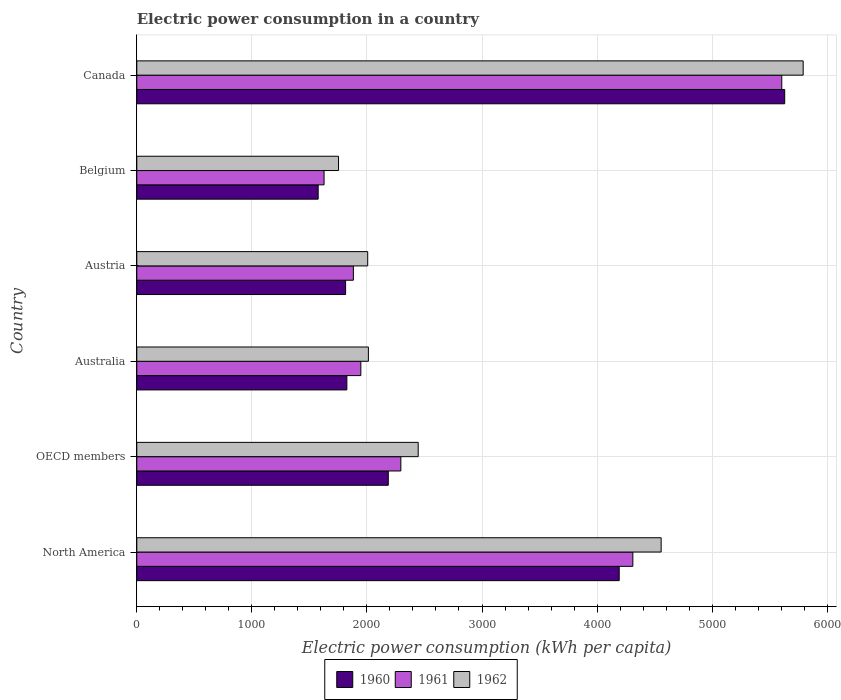How many different coloured bars are there?
Keep it short and to the point. 3. How many groups of bars are there?
Provide a short and direct response. 6. Are the number of bars per tick equal to the number of legend labels?
Ensure brevity in your answer.  Yes. What is the electric power consumption in in 1962 in Belgium?
Your answer should be compact. 1753.14. Across all countries, what is the maximum electric power consumption in in 1961?
Make the answer very short. 5605.11. Across all countries, what is the minimum electric power consumption in in 1961?
Your response must be concise. 1627.51. In which country was the electric power consumption in in 1961 minimum?
Keep it short and to the point. Belgium. What is the total electric power consumption in in 1962 in the graph?
Make the answer very short. 1.86e+04. What is the difference between the electric power consumption in in 1960 in Canada and that in North America?
Your answer should be very brief. 1438.27. What is the difference between the electric power consumption in in 1962 in Canada and the electric power consumption in in 1961 in Austria?
Provide a short and direct response. 3908.9. What is the average electric power consumption in in 1960 per country?
Your response must be concise. 2870.86. What is the difference between the electric power consumption in in 1962 and electric power consumption in in 1960 in Australia?
Provide a succinct answer. 187.03. What is the ratio of the electric power consumption in in 1961 in Austria to that in OECD members?
Offer a very short reply. 0.82. Is the electric power consumption in in 1961 in Canada less than that in OECD members?
Make the answer very short. No. Is the difference between the electric power consumption in in 1962 in Austria and North America greater than the difference between the electric power consumption in in 1960 in Austria and North America?
Your answer should be very brief. No. What is the difference between the highest and the second highest electric power consumption in in 1960?
Provide a short and direct response. 1438.27. What is the difference between the highest and the lowest electric power consumption in in 1962?
Offer a terse response. 4037.98. In how many countries, is the electric power consumption in in 1960 greater than the average electric power consumption in in 1960 taken over all countries?
Offer a very short reply. 2. Is the sum of the electric power consumption in in 1961 in Belgium and Canada greater than the maximum electric power consumption in in 1962 across all countries?
Keep it short and to the point. Yes. What does the 3rd bar from the top in Austria represents?
Ensure brevity in your answer.  1960. Is it the case that in every country, the sum of the electric power consumption in in 1960 and electric power consumption in in 1962 is greater than the electric power consumption in in 1961?
Provide a succinct answer. Yes. Are all the bars in the graph horizontal?
Keep it short and to the point. Yes. How many countries are there in the graph?
Offer a very short reply. 6. Does the graph contain any zero values?
Provide a short and direct response. No. Where does the legend appear in the graph?
Offer a terse response. Bottom center. How many legend labels are there?
Offer a very short reply. 3. What is the title of the graph?
Provide a short and direct response. Electric power consumption in a country. What is the label or title of the X-axis?
Your answer should be very brief. Electric power consumption (kWh per capita). What is the label or title of the Y-axis?
Your answer should be very brief. Country. What is the Electric power consumption (kWh per capita) in 1960 in North America?
Provide a short and direct response. 4192.36. What is the Electric power consumption (kWh per capita) in 1961 in North America?
Offer a very short reply. 4310.91. What is the Electric power consumption (kWh per capita) of 1962 in North America?
Your answer should be compact. 4556.78. What is the Electric power consumption (kWh per capita) in 1960 in OECD members?
Offer a terse response. 2185.53. What is the Electric power consumption (kWh per capita) of 1961 in OECD members?
Your answer should be compact. 2294.73. What is the Electric power consumption (kWh per capita) of 1962 in OECD members?
Offer a very short reply. 2445.52. What is the Electric power consumption (kWh per capita) in 1960 in Australia?
Your answer should be compact. 1825.63. What is the Electric power consumption (kWh per capita) of 1961 in Australia?
Provide a short and direct response. 1947.15. What is the Electric power consumption (kWh per capita) of 1962 in Australia?
Ensure brevity in your answer.  2012.66. What is the Electric power consumption (kWh per capita) of 1960 in Austria?
Give a very brief answer. 1814.68. What is the Electric power consumption (kWh per capita) of 1961 in Austria?
Make the answer very short. 1882.22. What is the Electric power consumption (kWh per capita) of 1962 in Austria?
Your answer should be compact. 2006.77. What is the Electric power consumption (kWh per capita) of 1960 in Belgium?
Keep it short and to the point. 1576.34. What is the Electric power consumption (kWh per capita) in 1961 in Belgium?
Your response must be concise. 1627.51. What is the Electric power consumption (kWh per capita) in 1962 in Belgium?
Your response must be concise. 1753.14. What is the Electric power consumption (kWh per capita) of 1960 in Canada?
Ensure brevity in your answer.  5630.63. What is the Electric power consumption (kWh per capita) of 1961 in Canada?
Provide a short and direct response. 5605.11. What is the Electric power consumption (kWh per capita) of 1962 in Canada?
Give a very brief answer. 5791.12. Across all countries, what is the maximum Electric power consumption (kWh per capita) of 1960?
Your answer should be very brief. 5630.63. Across all countries, what is the maximum Electric power consumption (kWh per capita) in 1961?
Give a very brief answer. 5605.11. Across all countries, what is the maximum Electric power consumption (kWh per capita) of 1962?
Your answer should be compact. 5791.12. Across all countries, what is the minimum Electric power consumption (kWh per capita) of 1960?
Your response must be concise. 1576.34. Across all countries, what is the minimum Electric power consumption (kWh per capita) in 1961?
Your response must be concise. 1627.51. Across all countries, what is the minimum Electric power consumption (kWh per capita) of 1962?
Offer a very short reply. 1753.14. What is the total Electric power consumption (kWh per capita) in 1960 in the graph?
Offer a very short reply. 1.72e+04. What is the total Electric power consumption (kWh per capita) of 1961 in the graph?
Keep it short and to the point. 1.77e+04. What is the total Electric power consumption (kWh per capita) in 1962 in the graph?
Offer a terse response. 1.86e+04. What is the difference between the Electric power consumption (kWh per capita) of 1960 in North America and that in OECD members?
Your answer should be very brief. 2006.82. What is the difference between the Electric power consumption (kWh per capita) in 1961 in North America and that in OECD members?
Provide a succinct answer. 2016.17. What is the difference between the Electric power consumption (kWh per capita) of 1962 in North America and that in OECD members?
Your response must be concise. 2111.25. What is the difference between the Electric power consumption (kWh per capita) in 1960 in North America and that in Australia?
Ensure brevity in your answer.  2366.73. What is the difference between the Electric power consumption (kWh per capita) in 1961 in North America and that in Australia?
Your answer should be compact. 2363.75. What is the difference between the Electric power consumption (kWh per capita) of 1962 in North America and that in Australia?
Your response must be concise. 2544.12. What is the difference between the Electric power consumption (kWh per capita) of 1960 in North America and that in Austria?
Give a very brief answer. 2377.68. What is the difference between the Electric power consumption (kWh per capita) in 1961 in North America and that in Austria?
Your answer should be very brief. 2428.68. What is the difference between the Electric power consumption (kWh per capita) of 1962 in North America and that in Austria?
Offer a terse response. 2550.01. What is the difference between the Electric power consumption (kWh per capita) of 1960 in North America and that in Belgium?
Provide a short and direct response. 2616.02. What is the difference between the Electric power consumption (kWh per capita) in 1961 in North America and that in Belgium?
Your answer should be compact. 2683.39. What is the difference between the Electric power consumption (kWh per capita) of 1962 in North America and that in Belgium?
Keep it short and to the point. 2803.63. What is the difference between the Electric power consumption (kWh per capita) in 1960 in North America and that in Canada?
Your answer should be compact. -1438.27. What is the difference between the Electric power consumption (kWh per capita) of 1961 in North America and that in Canada?
Your answer should be very brief. -1294.21. What is the difference between the Electric power consumption (kWh per capita) in 1962 in North America and that in Canada?
Your response must be concise. -1234.35. What is the difference between the Electric power consumption (kWh per capita) of 1960 in OECD members and that in Australia?
Give a very brief answer. 359.91. What is the difference between the Electric power consumption (kWh per capita) in 1961 in OECD members and that in Australia?
Your answer should be very brief. 347.58. What is the difference between the Electric power consumption (kWh per capita) of 1962 in OECD members and that in Australia?
Your answer should be compact. 432.86. What is the difference between the Electric power consumption (kWh per capita) of 1960 in OECD members and that in Austria?
Your answer should be compact. 370.86. What is the difference between the Electric power consumption (kWh per capita) in 1961 in OECD members and that in Austria?
Provide a short and direct response. 412.51. What is the difference between the Electric power consumption (kWh per capita) in 1962 in OECD members and that in Austria?
Offer a terse response. 438.75. What is the difference between the Electric power consumption (kWh per capita) in 1960 in OECD members and that in Belgium?
Provide a short and direct response. 609.19. What is the difference between the Electric power consumption (kWh per capita) of 1961 in OECD members and that in Belgium?
Keep it short and to the point. 667.22. What is the difference between the Electric power consumption (kWh per capita) in 1962 in OECD members and that in Belgium?
Make the answer very short. 692.38. What is the difference between the Electric power consumption (kWh per capita) of 1960 in OECD members and that in Canada?
Offer a terse response. -3445.1. What is the difference between the Electric power consumption (kWh per capita) of 1961 in OECD members and that in Canada?
Give a very brief answer. -3310.38. What is the difference between the Electric power consumption (kWh per capita) of 1962 in OECD members and that in Canada?
Provide a succinct answer. -3345.6. What is the difference between the Electric power consumption (kWh per capita) of 1960 in Australia and that in Austria?
Your answer should be very brief. 10.95. What is the difference between the Electric power consumption (kWh per capita) of 1961 in Australia and that in Austria?
Your answer should be compact. 64.93. What is the difference between the Electric power consumption (kWh per capita) of 1962 in Australia and that in Austria?
Give a very brief answer. 5.89. What is the difference between the Electric power consumption (kWh per capita) in 1960 in Australia and that in Belgium?
Your response must be concise. 249.29. What is the difference between the Electric power consumption (kWh per capita) in 1961 in Australia and that in Belgium?
Provide a short and direct response. 319.64. What is the difference between the Electric power consumption (kWh per capita) of 1962 in Australia and that in Belgium?
Provide a succinct answer. 259.52. What is the difference between the Electric power consumption (kWh per capita) of 1960 in Australia and that in Canada?
Provide a succinct answer. -3805. What is the difference between the Electric power consumption (kWh per capita) of 1961 in Australia and that in Canada?
Keep it short and to the point. -3657.96. What is the difference between the Electric power consumption (kWh per capita) of 1962 in Australia and that in Canada?
Offer a very short reply. -3778.46. What is the difference between the Electric power consumption (kWh per capita) of 1960 in Austria and that in Belgium?
Your answer should be very brief. 238.34. What is the difference between the Electric power consumption (kWh per capita) of 1961 in Austria and that in Belgium?
Your answer should be very brief. 254.71. What is the difference between the Electric power consumption (kWh per capita) in 1962 in Austria and that in Belgium?
Your answer should be compact. 253.63. What is the difference between the Electric power consumption (kWh per capita) in 1960 in Austria and that in Canada?
Keep it short and to the point. -3815.95. What is the difference between the Electric power consumption (kWh per capita) of 1961 in Austria and that in Canada?
Make the answer very short. -3722.89. What is the difference between the Electric power consumption (kWh per capita) in 1962 in Austria and that in Canada?
Make the answer very short. -3784.35. What is the difference between the Electric power consumption (kWh per capita) of 1960 in Belgium and that in Canada?
Offer a very short reply. -4054.29. What is the difference between the Electric power consumption (kWh per capita) of 1961 in Belgium and that in Canada?
Your answer should be compact. -3977.6. What is the difference between the Electric power consumption (kWh per capita) in 1962 in Belgium and that in Canada?
Provide a succinct answer. -4037.98. What is the difference between the Electric power consumption (kWh per capita) of 1960 in North America and the Electric power consumption (kWh per capita) of 1961 in OECD members?
Keep it short and to the point. 1897.62. What is the difference between the Electric power consumption (kWh per capita) of 1960 in North America and the Electric power consumption (kWh per capita) of 1962 in OECD members?
Your answer should be very brief. 1746.83. What is the difference between the Electric power consumption (kWh per capita) in 1961 in North America and the Electric power consumption (kWh per capita) in 1962 in OECD members?
Give a very brief answer. 1865.38. What is the difference between the Electric power consumption (kWh per capita) of 1960 in North America and the Electric power consumption (kWh per capita) of 1961 in Australia?
Offer a very short reply. 2245.2. What is the difference between the Electric power consumption (kWh per capita) of 1960 in North America and the Electric power consumption (kWh per capita) of 1962 in Australia?
Your answer should be very brief. 2179.7. What is the difference between the Electric power consumption (kWh per capita) of 1961 in North America and the Electric power consumption (kWh per capita) of 1962 in Australia?
Give a very brief answer. 2298.24. What is the difference between the Electric power consumption (kWh per capita) of 1960 in North America and the Electric power consumption (kWh per capita) of 1961 in Austria?
Your response must be concise. 2310.13. What is the difference between the Electric power consumption (kWh per capita) of 1960 in North America and the Electric power consumption (kWh per capita) of 1962 in Austria?
Provide a succinct answer. 2185.59. What is the difference between the Electric power consumption (kWh per capita) of 1961 in North America and the Electric power consumption (kWh per capita) of 1962 in Austria?
Provide a short and direct response. 2304.13. What is the difference between the Electric power consumption (kWh per capita) of 1960 in North America and the Electric power consumption (kWh per capita) of 1961 in Belgium?
Your answer should be compact. 2564.84. What is the difference between the Electric power consumption (kWh per capita) in 1960 in North America and the Electric power consumption (kWh per capita) in 1962 in Belgium?
Provide a short and direct response. 2439.21. What is the difference between the Electric power consumption (kWh per capita) in 1961 in North America and the Electric power consumption (kWh per capita) in 1962 in Belgium?
Your answer should be very brief. 2557.76. What is the difference between the Electric power consumption (kWh per capita) in 1960 in North America and the Electric power consumption (kWh per capita) in 1961 in Canada?
Offer a very short reply. -1412.76. What is the difference between the Electric power consumption (kWh per capita) of 1960 in North America and the Electric power consumption (kWh per capita) of 1962 in Canada?
Provide a succinct answer. -1598.77. What is the difference between the Electric power consumption (kWh per capita) of 1961 in North America and the Electric power consumption (kWh per capita) of 1962 in Canada?
Ensure brevity in your answer.  -1480.22. What is the difference between the Electric power consumption (kWh per capita) in 1960 in OECD members and the Electric power consumption (kWh per capita) in 1961 in Australia?
Provide a succinct answer. 238.38. What is the difference between the Electric power consumption (kWh per capita) in 1960 in OECD members and the Electric power consumption (kWh per capita) in 1962 in Australia?
Give a very brief answer. 172.87. What is the difference between the Electric power consumption (kWh per capita) in 1961 in OECD members and the Electric power consumption (kWh per capita) in 1962 in Australia?
Your answer should be very brief. 282.07. What is the difference between the Electric power consumption (kWh per capita) of 1960 in OECD members and the Electric power consumption (kWh per capita) of 1961 in Austria?
Keep it short and to the point. 303.31. What is the difference between the Electric power consumption (kWh per capita) of 1960 in OECD members and the Electric power consumption (kWh per capita) of 1962 in Austria?
Make the answer very short. 178.76. What is the difference between the Electric power consumption (kWh per capita) in 1961 in OECD members and the Electric power consumption (kWh per capita) in 1962 in Austria?
Ensure brevity in your answer.  287.96. What is the difference between the Electric power consumption (kWh per capita) in 1960 in OECD members and the Electric power consumption (kWh per capita) in 1961 in Belgium?
Provide a succinct answer. 558.02. What is the difference between the Electric power consumption (kWh per capita) in 1960 in OECD members and the Electric power consumption (kWh per capita) in 1962 in Belgium?
Offer a very short reply. 432.39. What is the difference between the Electric power consumption (kWh per capita) of 1961 in OECD members and the Electric power consumption (kWh per capita) of 1962 in Belgium?
Your response must be concise. 541.59. What is the difference between the Electric power consumption (kWh per capita) of 1960 in OECD members and the Electric power consumption (kWh per capita) of 1961 in Canada?
Offer a terse response. -3419.58. What is the difference between the Electric power consumption (kWh per capita) in 1960 in OECD members and the Electric power consumption (kWh per capita) in 1962 in Canada?
Your response must be concise. -3605.59. What is the difference between the Electric power consumption (kWh per capita) in 1961 in OECD members and the Electric power consumption (kWh per capita) in 1962 in Canada?
Your answer should be very brief. -3496.39. What is the difference between the Electric power consumption (kWh per capita) of 1960 in Australia and the Electric power consumption (kWh per capita) of 1961 in Austria?
Give a very brief answer. -56.6. What is the difference between the Electric power consumption (kWh per capita) in 1960 in Australia and the Electric power consumption (kWh per capita) in 1962 in Austria?
Keep it short and to the point. -181.14. What is the difference between the Electric power consumption (kWh per capita) in 1961 in Australia and the Electric power consumption (kWh per capita) in 1962 in Austria?
Your response must be concise. -59.62. What is the difference between the Electric power consumption (kWh per capita) of 1960 in Australia and the Electric power consumption (kWh per capita) of 1961 in Belgium?
Make the answer very short. 198.11. What is the difference between the Electric power consumption (kWh per capita) of 1960 in Australia and the Electric power consumption (kWh per capita) of 1962 in Belgium?
Your response must be concise. 72.48. What is the difference between the Electric power consumption (kWh per capita) in 1961 in Australia and the Electric power consumption (kWh per capita) in 1962 in Belgium?
Your answer should be very brief. 194.01. What is the difference between the Electric power consumption (kWh per capita) in 1960 in Australia and the Electric power consumption (kWh per capita) in 1961 in Canada?
Offer a very short reply. -3779.49. What is the difference between the Electric power consumption (kWh per capita) of 1960 in Australia and the Electric power consumption (kWh per capita) of 1962 in Canada?
Provide a succinct answer. -3965.5. What is the difference between the Electric power consumption (kWh per capita) of 1961 in Australia and the Electric power consumption (kWh per capita) of 1962 in Canada?
Offer a terse response. -3843.97. What is the difference between the Electric power consumption (kWh per capita) of 1960 in Austria and the Electric power consumption (kWh per capita) of 1961 in Belgium?
Ensure brevity in your answer.  187.16. What is the difference between the Electric power consumption (kWh per capita) of 1960 in Austria and the Electric power consumption (kWh per capita) of 1962 in Belgium?
Give a very brief answer. 61.53. What is the difference between the Electric power consumption (kWh per capita) in 1961 in Austria and the Electric power consumption (kWh per capita) in 1962 in Belgium?
Your answer should be very brief. 129.08. What is the difference between the Electric power consumption (kWh per capita) of 1960 in Austria and the Electric power consumption (kWh per capita) of 1961 in Canada?
Offer a terse response. -3790.44. What is the difference between the Electric power consumption (kWh per capita) in 1960 in Austria and the Electric power consumption (kWh per capita) in 1962 in Canada?
Offer a terse response. -3976.45. What is the difference between the Electric power consumption (kWh per capita) of 1961 in Austria and the Electric power consumption (kWh per capita) of 1962 in Canada?
Your response must be concise. -3908.9. What is the difference between the Electric power consumption (kWh per capita) in 1960 in Belgium and the Electric power consumption (kWh per capita) in 1961 in Canada?
Ensure brevity in your answer.  -4028.77. What is the difference between the Electric power consumption (kWh per capita) in 1960 in Belgium and the Electric power consumption (kWh per capita) in 1962 in Canada?
Provide a short and direct response. -4214.79. What is the difference between the Electric power consumption (kWh per capita) of 1961 in Belgium and the Electric power consumption (kWh per capita) of 1962 in Canada?
Your response must be concise. -4163.61. What is the average Electric power consumption (kWh per capita) in 1960 per country?
Give a very brief answer. 2870.86. What is the average Electric power consumption (kWh per capita) of 1961 per country?
Offer a terse response. 2944.61. What is the average Electric power consumption (kWh per capita) of 1962 per country?
Your answer should be very brief. 3094.33. What is the difference between the Electric power consumption (kWh per capita) in 1960 and Electric power consumption (kWh per capita) in 1961 in North America?
Make the answer very short. -118.55. What is the difference between the Electric power consumption (kWh per capita) of 1960 and Electric power consumption (kWh per capita) of 1962 in North America?
Offer a terse response. -364.42. What is the difference between the Electric power consumption (kWh per capita) in 1961 and Electric power consumption (kWh per capita) in 1962 in North America?
Provide a short and direct response. -245.87. What is the difference between the Electric power consumption (kWh per capita) of 1960 and Electric power consumption (kWh per capita) of 1961 in OECD members?
Give a very brief answer. -109.2. What is the difference between the Electric power consumption (kWh per capita) in 1960 and Electric power consumption (kWh per capita) in 1962 in OECD members?
Provide a short and direct response. -259.99. What is the difference between the Electric power consumption (kWh per capita) of 1961 and Electric power consumption (kWh per capita) of 1962 in OECD members?
Give a very brief answer. -150.79. What is the difference between the Electric power consumption (kWh per capita) of 1960 and Electric power consumption (kWh per capita) of 1961 in Australia?
Your answer should be compact. -121.53. What is the difference between the Electric power consumption (kWh per capita) in 1960 and Electric power consumption (kWh per capita) in 1962 in Australia?
Your answer should be compact. -187.03. What is the difference between the Electric power consumption (kWh per capita) of 1961 and Electric power consumption (kWh per capita) of 1962 in Australia?
Make the answer very short. -65.51. What is the difference between the Electric power consumption (kWh per capita) of 1960 and Electric power consumption (kWh per capita) of 1961 in Austria?
Offer a very short reply. -67.55. What is the difference between the Electric power consumption (kWh per capita) of 1960 and Electric power consumption (kWh per capita) of 1962 in Austria?
Your answer should be very brief. -192.09. What is the difference between the Electric power consumption (kWh per capita) of 1961 and Electric power consumption (kWh per capita) of 1962 in Austria?
Make the answer very short. -124.55. What is the difference between the Electric power consumption (kWh per capita) in 1960 and Electric power consumption (kWh per capita) in 1961 in Belgium?
Ensure brevity in your answer.  -51.17. What is the difference between the Electric power consumption (kWh per capita) in 1960 and Electric power consumption (kWh per capita) in 1962 in Belgium?
Offer a terse response. -176.81. What is the difference between the Electric power consumption (kWh per capita) of 1961 and Electric power consumption (kWh per capita) of 1962 in Belgium?
Your response must be concise. -125.63. What is the difference between the Electric power consumption (kWh per capita) of 1960 and Electric power consumption (kWh per capita) of 1961 in Canada?
Your answer should be very brief. 25.52. What is the difference between the Electric power consumption (kWh per capita) of 1960 and Electric power consumption (kWh per capita) of 1962 in Canada?
Ensure brevity in your answer.  -160.5. What is the difference between the Electric power consumption (kWh per capita) in 1961 and Electric power consumption (kWh per capita) in 1962 in Canada?
Keep it short and to the point. -186.01. What is the ratio of the Electric power consumption (kWh per capita) of 1960 in North America to that in OECD members?
Your answer should be very brief. 1.92. What is the ratio of the Electric power consumption (kWh per capita) in 1961 in North America to that in OECD members?
Give a very brief answer. 1.88. What is the ratio of the Electric power consumption (kWh per capita) in 1962 in North America to that in OECD members?
Give a very brief answer. 1.86. What is the ratio of the Electric power consumption (kWh per capita) of 1960 in North America to that in Australia?
Ensure brevity in your answer.  2.3. What is the ratio of the Electric power consumption (kWh per capita) of 1961 in North America to that in Australia?
Your answer should be compact. 2.21. What is the ratio of the Electric power consumption (kWh per capita) in 1962 in North America to that in Australia?
Keep it short and to the point. 2.26. What is the ratio of the Electric power consumption (kWh per capita) of 1960 in North America to that in Austria?
Make the answer very short. 2.31. What is the ratio of the Electric power consumption (kWh per capita) of 1961 in North America to that in Austria?
Ensure brevity in your answer.  2.29. What is the ratio of the Electric power consumption (kWh per capita) in 1962 in North America to that in Austria?
Your answer should be compact. 2.27. What is the ratio of the Electric power consumption (kWh per capita) of 1960 in North America to that in Belgium?
Make the answer very short. 2.66. What is the ratio of the Electric power consumption (kWh per capita) of 1961 in North America to that in Belgium?
Ensure brevity in your answer.  2.65. What is the ratio of the Electric power consumption (kWh per capita) in 1962 in North America to that in Belgium?
Offer a very short reply. 2.6. What is the ratio of the Electric power consumption (kWh per capita) in 1960 in North America to that in Canada?
Your response must be concise. 0.74. What is the ratio of the Electric power consumption (kWh per capita) of 1961 in North America to that in Canada?
Make the answer very short. 0.77. What is the ratio of the Electric power consumption (kWh per capita) of 1962 in North America to that in Canada?
Give a very brief answer. 0.79. What is the ratio of the Electric power consumption (kWh per capita) of 1960 in OECD members to that in Australia?
Keep it short and to the point. 1.2. What is the ratio of the Electric power consumption (kWh per capita) in 1961 in OECD members to that in Australia?
Provide a succinct answer. 1.18. What is the ratio of the Electric power consumption (kWh per capita) in 1962 in OECD members to that in Australia?
Provide a succinct answer. 1.22. What is the ratio of the Electric power consumption (kWh per capita) in 1960 in OECD members to that in Austria?
Ensure brevity in your answer.  1.2. What is the ratio of the Electric power consumption (kWh per capita) of 1961 in OECD members to that in Austria?
Provide a succinct answer. 1.22. What is the ratio of the Electric power consumption (kWh per capita) in 1962 in OECD members to that in Austria?
Your response must be concise. 1.22. What is the ratio of the Electric power consumption (kWh per capita) in 1960 in OECD members to that in Belgium?
Provide a short and direct response. 1.39. What is the ratio of the Electric power consumption (kWh per capita) of 1961 in OECD members to that in Belgium?
Give a very brief answer. 1.41. What is the ratio of the Electric power consumption (kWh per capita) in 1962 in OECD members to that in Belgium?
Offer a very short reply. 1.39. What is the ratio of the Electric power consumption (kWh per capita) in 1960 in OECD members to that in Canada?
Your response must be concise. 0.39. What is the ratio of the Electric power consumption (kWh per capita) of 1961 in OECD members to that in Canada?
Provide a short and direct response. 0.41. What is the ratio of the Electric power consumption (kWh per capita) of 1962 in OECD members to that in Canada?
Give a very brief answer. 0.42. What is the ratio of the Electric power consumption (kWh per capita) in 1961 in Australia to that in Austria?
Provide a short and direct response. 1.03. What is the ratio of the Electric power consumption (kWh per capita) in 1962 in Australia to that in Austria?
Keep it short and to the point. 1. What is the ratio of the Electric power consumption (kWh per capita) in 1960 in Australia to that in Belgium?
Offer a terse response. 1.16. What is the ratio of the Electric power consumption (kWh per capita) of 1961 in Australia to that in Belgium?
Provide a succinct answer. 1.2. What is the ratio of the Electric power consumption (kWh per capita) of 1962 in Australia to that in Belgium?
Give a very brief answer. 1.15. What is the ratio of the Electric power consumption (kWh per capita) of 1960 in Australia to that in Canada?
Your answer should be compact. 0.32. What is the ratio of the Electric power consumption (kWh per capita) in 1961 in Australia to that in Canada?
Your answer should be compact. 0.35. What is the ratio of the Electric power consumption (kWh per capita) in 1962 in Australia to that in Canada?
Your answer should be compact. 0.35. What is the ratio of the Electric power consumption (kWh per capita) in 1960 in Austria to that in Belgium?
Your response must be concise. 1.15. What is the ratio of the Electric power consumption (kWh per capita) in 1961 in Austria to that in Belgium?
Your response must be concise. 1.16. What is the ratio of the Electric power consumption (kWh per capita) in 1962 in Austria to that in Belgium?
Provide a succinct answer. 1.14. What is the ratio of the Electric power consumption (kWh per capita) in 1960 in Austria to that in Canada?
Your answer should be very brief. 0.32. What is the ratio of the Electric power consumption (kWh per capita) of 1961 in Austria to that in Canada?
Your answer should be very brief. 0.34. What is the ratio of the Electric power consumption (kWh per capita) of 1962 in Austria to that in Canada?
Your response must be concise. 0.35. What is the ratio of the Electric power consumption (kWh per capita) of 1960 in Belgium to that in Canada?
Provide a succinct answer. 0.28. What is the ratio of the Electric power consumption (kWh per capita) in 1961 in Belgium to that in Canada?
Your answer should be very brief. 0.29. What is the ratio of the Electric power consumption (kWh per capita) of 1962 in Belgium to that in Canada?
Offer a terse response. 0.3. What is the difference between the highest and the second highest Electric power consumption (kWh per capita) of 1960?
Your answer should be compact. 1438.27. What is the difference between the highest and the second highest Electric power consumption (kWh per capita) in 1961?
Your answer should be compact. 1294.21. What is the difference between the highest and the second highest Electric power consumption (kWh per capita) in 1962?
Your answer should be compact. 1234.35. What is the difference between the highest and the lowest Electric power consumption (kWh per capita) in 1960?
Offer a very short reply. 4054.29. What is the difference between the highest and the lowest Electric power consumption (kWh per capita) of 1961?
Make the answer very short. 3977.6. What is the difference between the highest and the lowest Electric power consumption (kWh per capita) of 1962?
Give a very brief answer. 4037.98. 